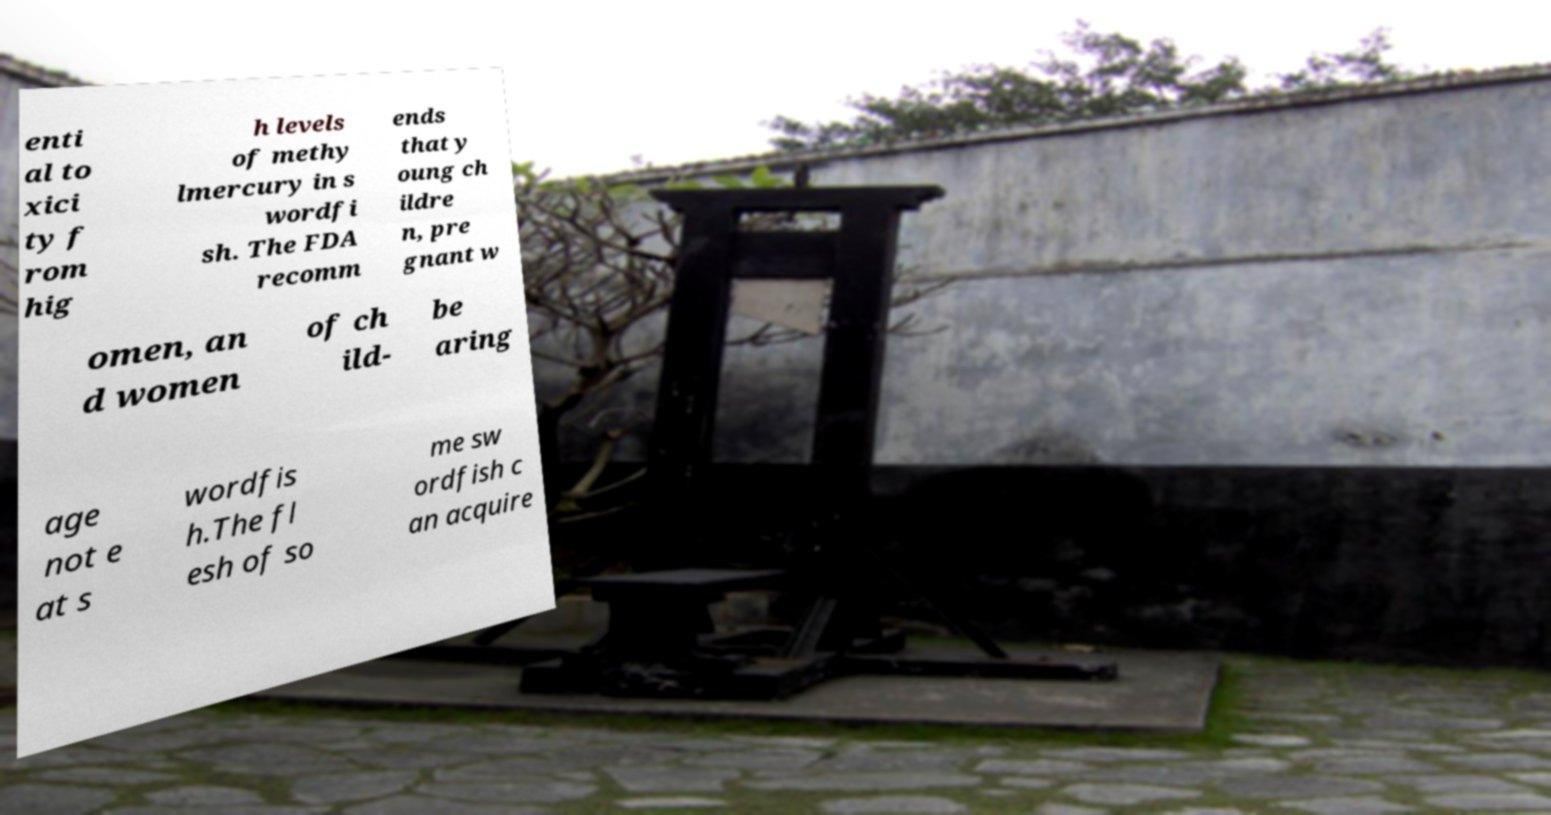For documentation purposes, I need the text within this image transcribed. Could you provide that? enti al to xici ty f rom hig h levels of methy lmercury in s wordfi sh. The FDA recomm ends that y oung ch ildre n, pre gnant w omen, an d women of ch ild- be aring age not e at s wordfis h.The fl esh of so me sw ordfish c an acquire 